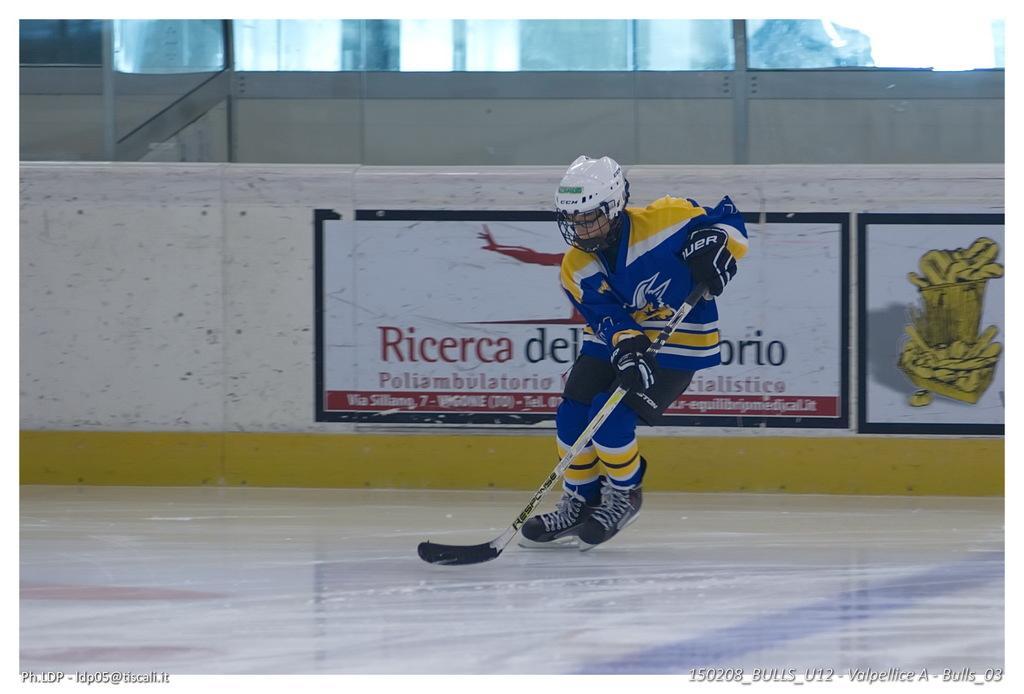Describe this image in one or two sentences. In this image we can see a person, holding a stick and playing some game. 